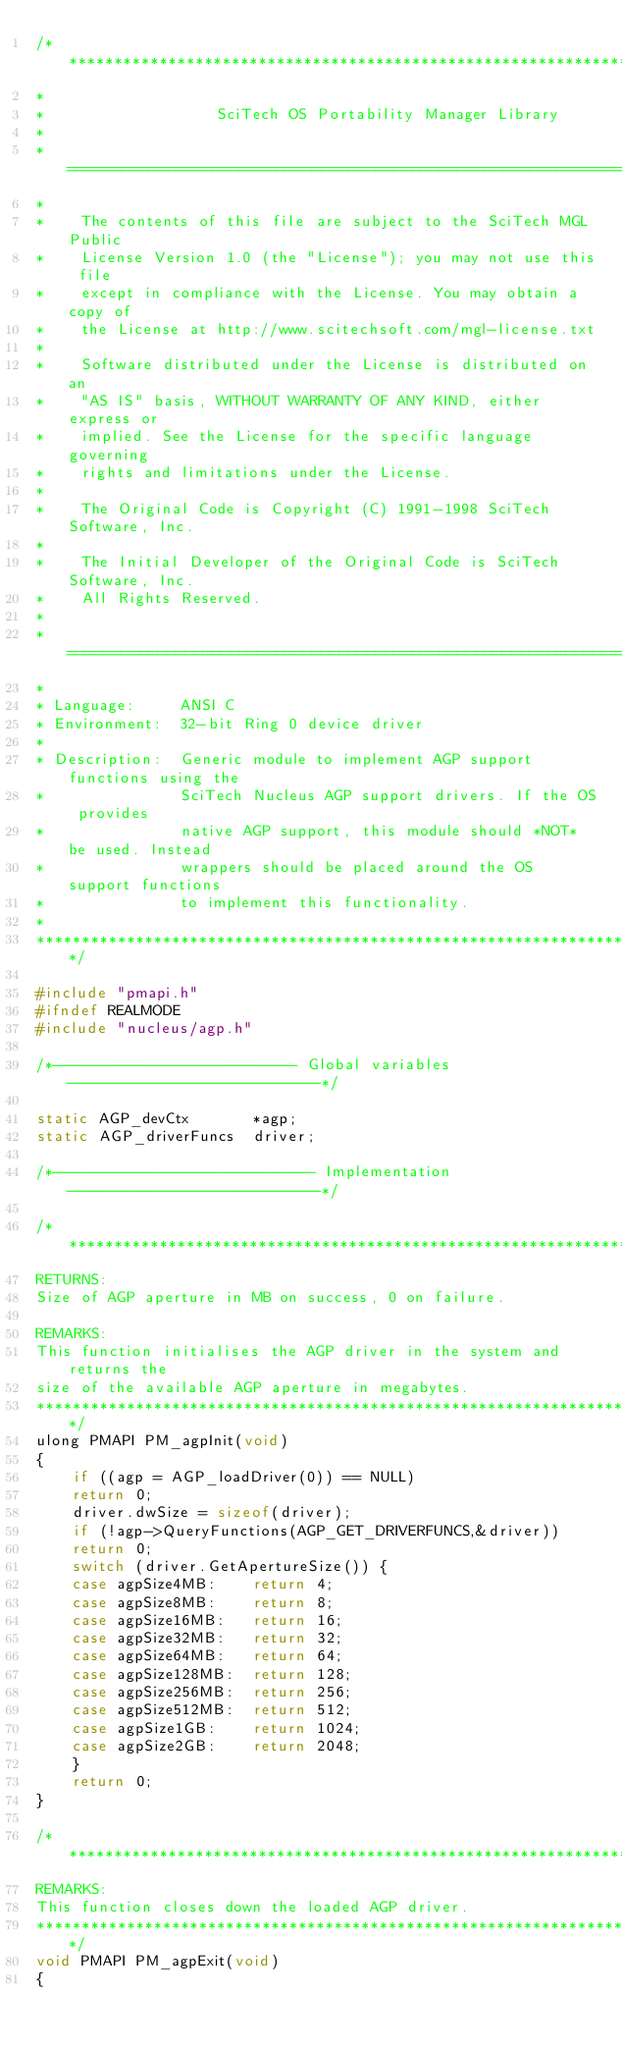Convert code to text. <code><loc_0><loc_0><loc_500><loc_500><_C_>/****************************************************************************
*
*                   SciTech OS Portability Manager Library
*
*  ========================================================================
*
*    The contents of this file are subject to the SciTech MGL Public
*    License Version 1.0 (the "License"); you may not use this file
*    except in compliance with the License. You may obtain a copy of
*    the License at http://www.scitechsoft.com/mgl-license.txt
*
*    Software distributed under the License is distributed on an
*    "AS IS" basis, WITHOUT WARRANTY OF ANY KIND, either express or
*    implied. See the License for the specific language governing
*    rights and limitations under the License.
*
*    The Original Code is Copyright (C) 1991-1998 SciTech Software, Inc.
*
*    The Initial Developer of the Original Code is SciTech Software, Inc.
*    All Rights Reserved.
*
*  ========================================================================
*
* Language:     ANSI C
* Environment:  32-bit Ring 0 device driver
*
* Description:  Generic module to implement AGP support functions using the
*               SciTech Nucleus AGP support drivers. If the OS provides
*               native AGP support, this module should *NOT* be used. Instead
*               wrappers should be placed around the OS support functions
*               to implement this functionality.
*
****************************************************************************/

#include "pmapi.h"
#ifndef REALMODE
#include "nucleus/agp.h"

/*--------------------------- Global variables ----------------------------*/

static AGP_devCtx       *agp;
static AGP_driverFuncs  driver;

/*----------------------------- Implementation ----------------------------*/

/****************************************************************************
RETURNS:
Size of AGP aperture in MB on success, 0 on failure.

REMARKS:
This function initialises the AGP driver in the system and returns the
size of the available AGP aperture in megabytes.
****************************************************************************/
ulong PMAPI PM_agpInit(void)
{
    if ((agp = AGP_loadDriver(0)) == NULL)
	return 0;
    driver.dwSize = sizeof(driver);
    if (!agp->QueryFunctions(AGP_GET_DRIVERFUNCS,&driver))
	return 0;
    switch (driver.GetApertureSize()) {
	case agpSize4MB:    return 4;
	case agpSize8MB:    return 8;
	case agpSize16MB:   return 16;
	case agpSize32MB:   return 32;
	case agpSize64MB:   return 64;
	case agpSize128MB:  return 128;
	case agpSize256MB:  return 256;
	case agpSize512MB:  return 512;
	case agpSize1GB:    return 1024;
	case agpSize2GB:    return 2048;
	}
    return 0;
}

/****************************************************************************
REMARKS:
This function closes down the loaded AGP driver.
****************************************************************************/
void PMAPI PM_agpExit(void)
{</code> 